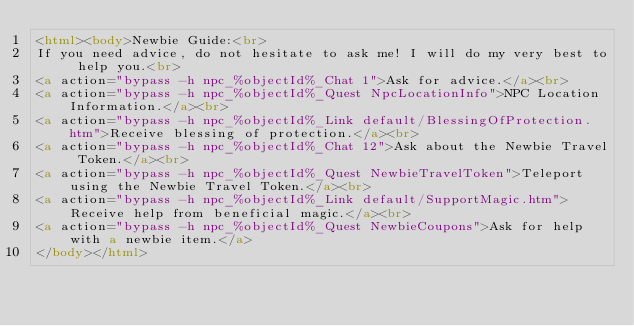<code> <loc_0><loc_0><loc_500><loc_500><_HTML_><html><body>Newbie Guide:<br>
If you need advice, do not hesitate to ask me! I will do my very best to help you.<br>
<a action="bypass -h npc_%objectId%_Chat 1">Ask for advice.</a><br>
<a action="bypass -h npc_%objectId%_Quest NpcLocationInfo">NPC Location Information.</a><br>
<a action="bypass -h npc_%objectId%_Link default/BlessingOfProtection.htm">Receive blessing of protection.</a><br>
<a action="bypass -h npc_%objectId%_Chat 12">Ask about the Newbie Travel Token.</a><br>
<a action="bypass -h npc_%objectId%_Quest NewbieTravelToken">Teleport using the Newbie Travel Token.</a><br>
<a action="bypass -h npc_%objectId%_Link default/SupportMagic.htm">Receive help from beneficial magic.</a><br>
<a action="bypass -h npc_%objectId%_Quest NewbieCoupons">Ask for help with a newbie item.</a>
</body></html></code> 